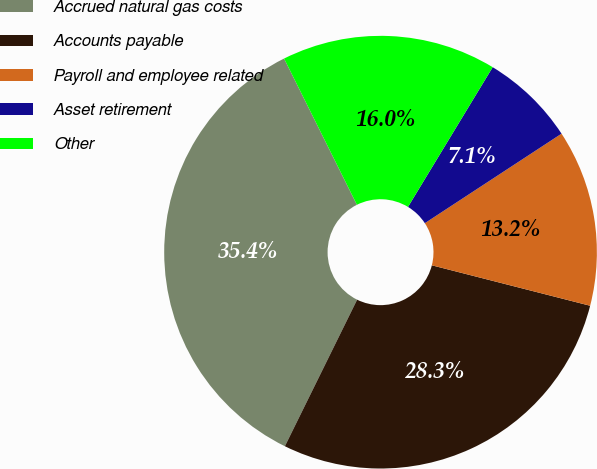Convert chart to OTSL. <chart><loc_0><loc_0><loc_500><loc_500><pie_chart><fcel>Accrued natural gas costs<fcel>Accounts payable<fcel>Payroll and employee related<fcel>Asset retirement<fcel>Other<nl><fcel>35.36%<fcel>28.31%<fcel>13.21%<fcel>7.1%<fcel>16.03%<nl></chart> 